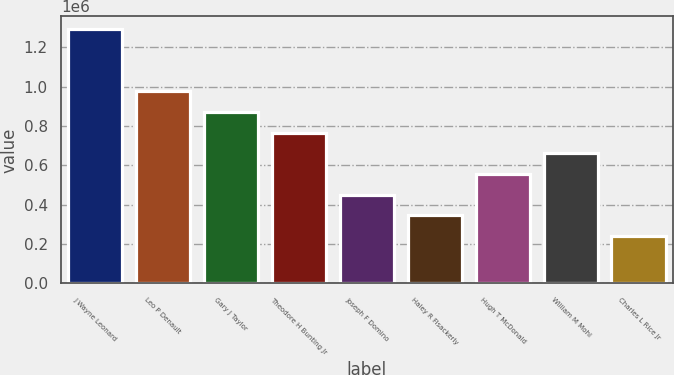Convert chart to OTSL. <chart><loc_0><loc_0><loc_500><loc_500><bar_chart><fcel>J Wayne Leonard<fcel>Leo P Denault<fcel>Gary J Taylor<fcel>Theodore H Bunting Jr<fcel>Joseph F Domino<fcel>Haley R Fisackerly<fcel>Hugh T McDonald<fcel>William M Mohl<fcel>Charles L Rice Jr<nl><fcel>1.2915e+06<fcel>976050<fcel>870900<fcel>765750<fcel>450300<fcel>345150<fcel>555450<fcel>660600<fcel>240000<nl></chart> 